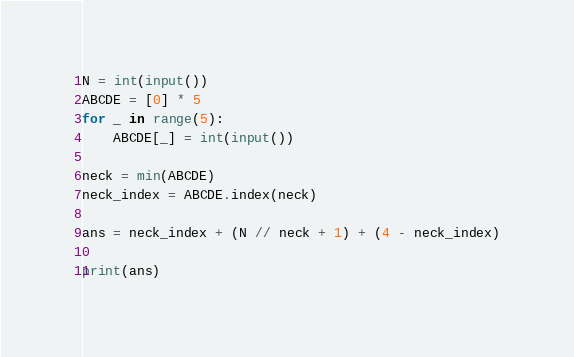<code> <loc_0><loc_0><loc_500><loc_500><_Python_>N = int(input())
ABCDE = [0] * 5
for _ in range(5):
    ABCDE[_] = int(input())

neck = min(ABCDE)
neck_index = ABCDE.index(neck)

ans = neck_index + (N // neck + 1) + (4 - neck_index)

print(ans)
</code> 